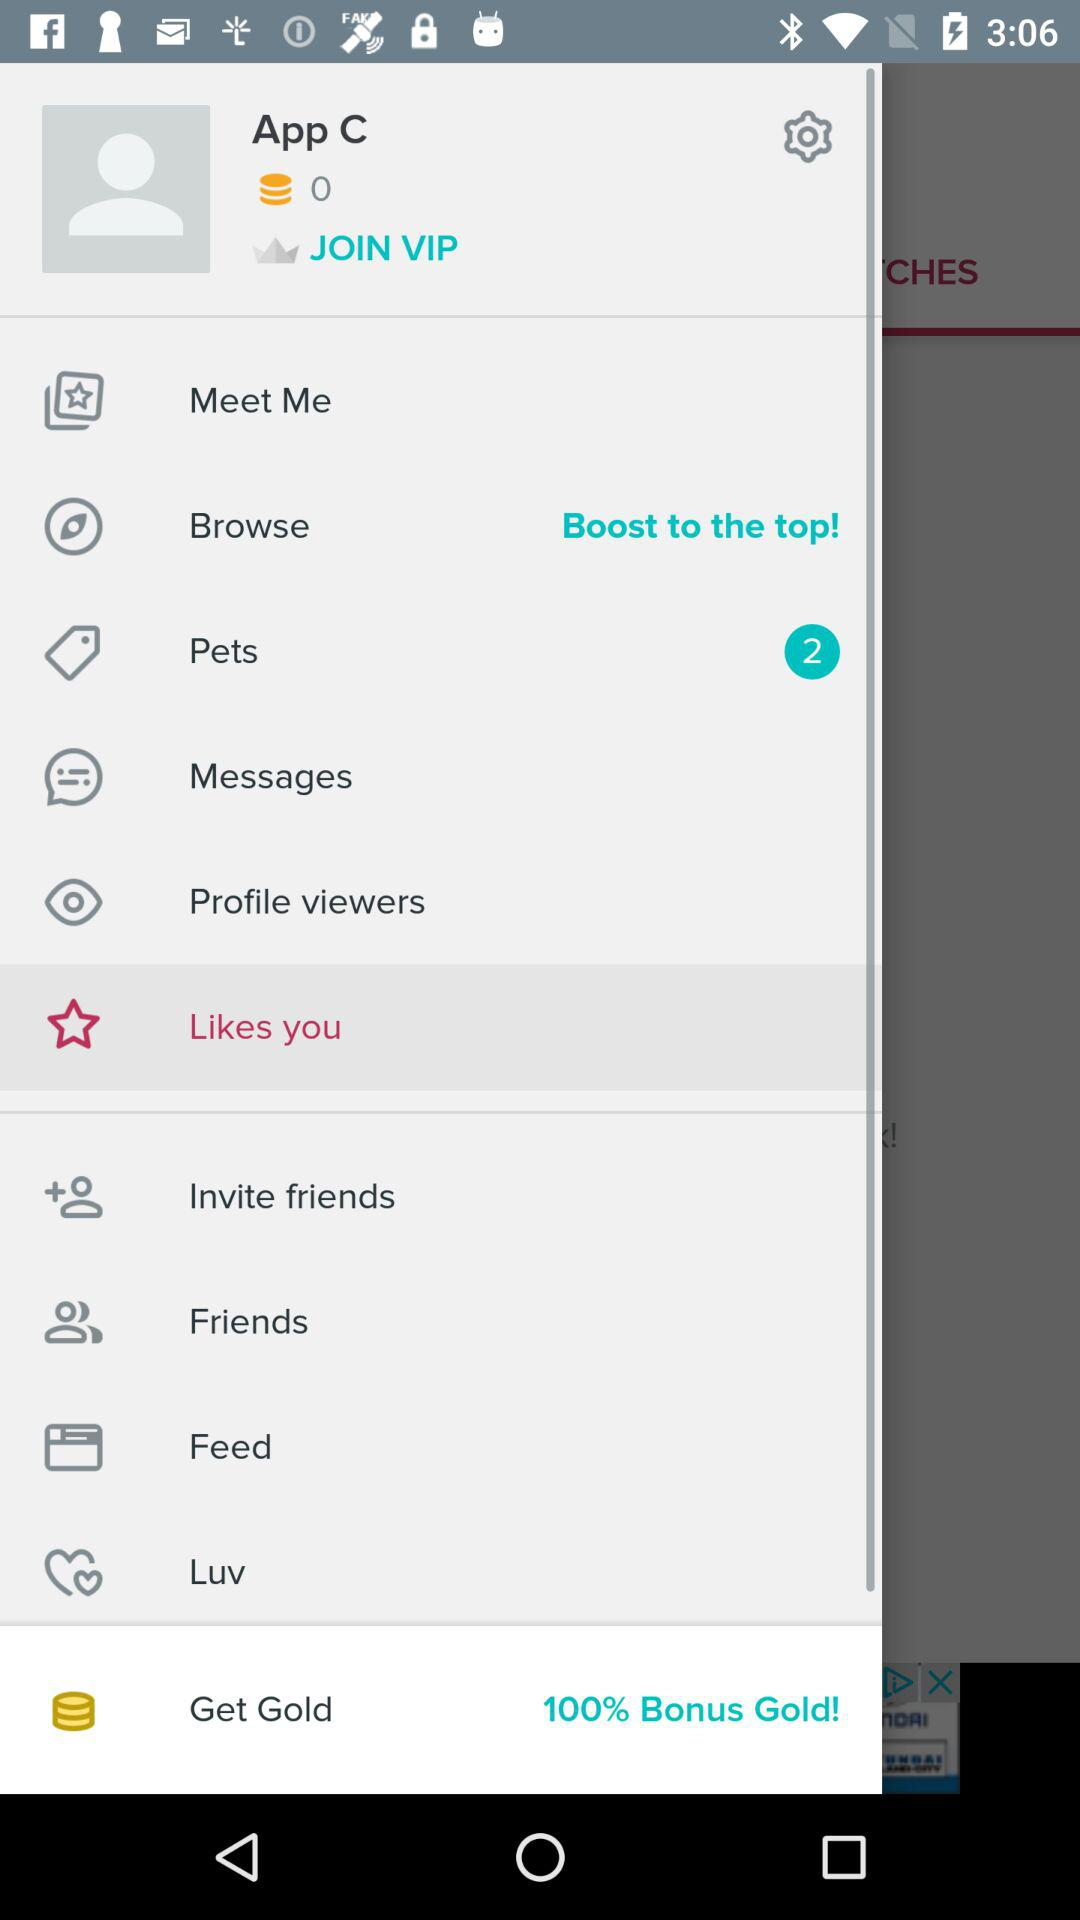What is the percentage of the bonus gold? The bonus gold is 100%. 